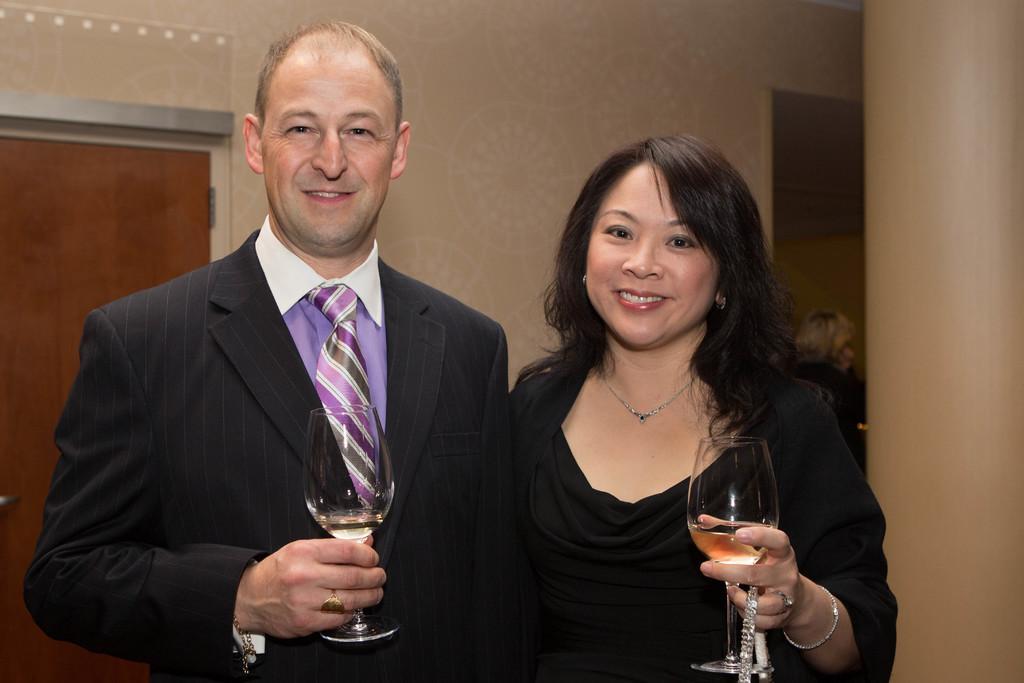How would you summarize this image in a sentence or two? In this picture we can see man and woman holding glasses in their hand and smiling and in background we can see door, wall, frame, pillar. 